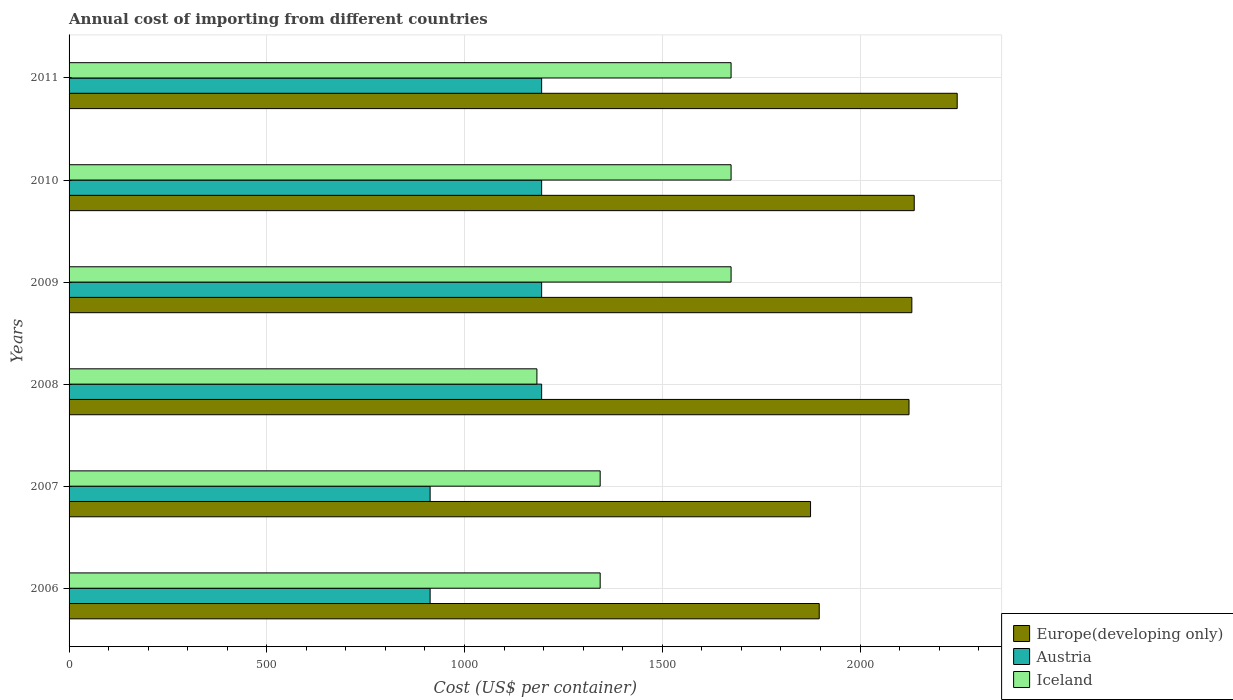How many different coloured bars are there?
Offer a terse response. 3. How many groups of bars are there?
Your answer should be very brief. 6. In how many cases, is the number of bars for a given year not equal to the number of legend labels?
Keep it short and to the point. 0. What is the total annual cost of importing in Austria in 2010?
Offer a very short reply. 1195. Across all years, what is the maximum total annual cost of importing in Iceland?
Give a very brief answer. 1674. Across all years, what is the minimum total annual cost of importing in Europe(developing only)?
Offer a very short reply. 1874.94. In which year was the total annual cost of importing in Austria maximum?
Your answer should be compact. 2008. In which year was the total annual cost of importing in Iceland minimum?
Make the answer very short. 2008. What is the total total annual cost of importing in Iceland in the graph?
Give a very brief answer. 8891. What is the difference between the total annual cost of importing in Europe(developing only) in 2006 and that in 2009?
Provide a succinct answer. -234.16. What is the difference between the total annual cost of importing in Austria in 2010 and the total annual cost of importing in Iceland in 2008?
Make the answer very short. 12. What is the average total annual cost of importing in Iceland per year?
Make the answer very short. 1481.83. In the year 2006, what is the difference between the total annual cost of importing in Europe(developing only) and total annual cost of importing in Austria?
Keep it short and to the point. 983.94. What is the ratio of the total annual cost of importing in Iceland in 2006 to that in 2010?
Provide a short and direct response. 0.8. What is the difference between the highest and the second highest total annual cost of importing in Europe(developing only)?
Keep it short and to the point. 108.63. What is the difference between the highest and the lowest total annual cost of importing in Europe(developing only)?
Provide a succinct answer. 370.85. In how many years, is the total annual cost of importing in Austria greater than the average total annual cost of importing in Austria taken over all years?
Keep it short and to the point. 4. What does the 1st bar from the top in 2011 represents?
Your answer should be compact. Iceland. How many years are there in the graph?
Offer a very short reply. 6. Does the graph contain any zero values?
Give a very brief answer. No. Does the graph contain grids?
Keep it short and to the point. Yes. What is the title of the graph?
Make the answer very short. Annual cost of importing from different countries. Does "Burundi" appear as one of the legend labels in the graph?
Provide a succinct answer. No. What is the label or title of the X-axis?
Provide a short and direct response. Cost (US$ per container). What is the label or title of the Y-axis?
Offer a very short reply. Years. What is the Cost (US$ per container) in Europe(developing only) in 2006?
Your answer should be very brief. 1896.94. What is the Cost (US$ per container) in Austria in 2006?
Give a very brief answer. 913. What is the Cost (US$ per container) in Iceland in 2006?
Keep it short and to the point. 1343. What is the Cost (US$ per container) of Europe(developing only) in 2007?
Offer a terse response. 1874.94. What is the Cost (US$ per container) in Austria in 2007?
Keep it short and to the point. 913. What is the Cost (US$ per container) in Iceland in 2007?
Your answer should be very brief. 1343. What is the Cost (US$ per container) of Europe(developing only) in 2008?
Offer a very short reply. 2123.94. What is the Cost (US$ per container) in Austria in 2008?
Offer a terse response. 1195. What is the Cost (US$ per container) in Iceland in 2008?
Your answer should be compact. 1183. What is the Cost (US$ per container) of Europe(developing only) in 2009?
Make the answer very short. 2131.11. What is the Cost (US$ per container) in Austria in 2009?
Your response must be concise. 1195. What is the Cost (US$ per container) in Iceland in 2009?
Your response must be concise. 1674. What is the Cost (US$ per container) of Europe(developing only) in 2010?
Your answer should be compact. 2137.16. What is the Cost (US$ per container) in Austria in 2010?
Your answer should be compact. 1195. What is the Cost (US$ per container) of Iceland in 2010?
Offer a very short reply. 1674. What is the Cost (US$ per container) in Europe(developing only) in 2011?
Make the answer very short. 2245.79. What is the Cost (US$ per container) in Austria in 2011?
Provide a short and direct response. 1195. What is the Cost (US$ per container) in Iceland in 2011?
Ensure brevity in your answer.  1674. Across all years, what is the maximum Cost (US$ per container) of Europe(developing only)?
Offer a terse response. 2245.79. Across all years, what is the maximum Cost (US$ per container) in Austria?
Give a very brief answer. 1195. Across all years, what is the maximum Cost (US$ per container) of Iceland?
Provide a short and direct response. 1674. Across all years, what is the minimum Cost (US$ per container) in Europe(developing only)?
Give a very brief answer. 1874.94. Across all years, what is the minimum Cost (US$ per container) in Austria?
Offer a terse response. 913. Across all years, what is the minimum Cost (US$ per container) of Iceland?
Make the answer very short. 1183. What is the total Cost (US$ per container) in Europe(developing only) in the graph?
Provide a succinct answer. 1.24e+04. What is the total Cost (US$ per container) in Austria in the graph?
Provide a succinct answer. 6606. What is the total Cost (US$ per container) in Iceland in the graph?
Give a very brief answer. 8891. What is the difference between the Cost (US$ per container) in Europe(developing only) in 2006 and that in 2007?
Provide a short and direct response. 22. What is the difference between the Cost (US$ per container) in Austria in 2006 and that in 2007?
Your answer should be very brief. 0. What is the difference between the Cost (US$ per container) of Europe(developing only) in 2006 and that in 2008?
Your answer should be very brief. -227. What is the difference between the Cost (US$ per container) of Austria in 2006 and that in 2008?
Keep it short and to the point. -282. What is the difference between the Cost (US$ per container) in Iceland in 2006 and that in 2008?
Give a very brief answer. 160. What is the difference between the Cost (US$ per container) of Europe(developing only) in 2006 and that in 2009?
Provide a succinct answer. -234.16. What is the difference between the Cost (US$ per container) of Austria in 2006 and that in 2009?
Provide a succinct answer. -282. What is the difference between the Cost (US$ per container) in Iceland in 2006 and that in 2009?
Offer a very short reply. -331. What is the difference between the Cost (US$ per container) in Europe(developing only) in 2006 and that in 2010?
Your answer should be very brief. -240.21. What is the difference between the Cost (US$ per container) in Austria in 2006 and that in 2010?
Provide a succinct answer. -282. What is the difference between the Cost (US$ per container) in Iceland in 2006 and that in 2010?
Your answer should be compact. -331. What is the difference between the Cost (US$ per container) in Europe(developing only) in 2006 and that in 2011?
Keep it short and to the point. -348.85. What is the difference between the Cost (US$ per container) in Austria in 2006 and that in 2011?
Offer a terse response. -282. What is the difference between the Cost (US$ per container) of Iceland in 2006 and that in 2011?
Make the answer very short. -331. What is the difference between the Cost (US$ per container) of Europe(developing only) in 2007 and that in 2008?
Give a very brief answer. -249. What is the difference between the Cost (US$ per container) of Austria in 2007 and that in 2008?
Offer a terse response. -282. What is the difference between the Cost (US$ per container) of Iceland in 2007 and that in 2008?
Keep it short and to the point. 160. What is the difference between the Cost (US$ per container) in Europe(developing only) in 2007 and that in 2009?
Offer a very short reply. -256.16. What is the difference between the Cost (US$ per container) in Austria in 2007 and that in 2009?
Your answer should be compact. -282. What is the difference between the Cost (US$ per container) of Iceland in 2007 and that in 2009?
Keep it short and to the point. -331. What is the difference between the Cost (US$ per container) of Europe(developing only) in 2007 and that in 2010?
Keep it short and to the point. -262.21. What is the difference between the Cost (US$ per container) of Austria in 2007 and that in 2010?
Your response must be concise. -282. What is the difference between the Cost (US$ per container) of Iceland in 2007 and that in 2010?
Give a very brief answer. -331. What is the difference between the Cost (US$ per container) of Europe(developing only) in 2007 and that in 2011?
Your answer should be compact. -370.85. What is the difference between the Cost (US$ per container) in Austria in 2007 and that in 2011?
Your response must be concise. -282. What is the difference between the Cost (US$ per container) in Iceland in 2007 and that in 2011?
Provide a short and direct response. -331. What is the difference between the Cost (US$ per container) in Europe(developing only) in 2008 and that in 2009?
Keep it short and to the point. -7.16. What is the difference between the Cost (US$ per container) of Austria in 2008 and that in 2009?
Ensure brevity in your answer.  0. What is the difference between the Cost (US$ per container) in Iceland in 2008 and that in 2009?
Provide a short and direct response. -491. What is the difference between the Cost (US$ per container) of Europe(developing only) in 2008 and that in 2010?
Your answer should be very brief. -13.21. What is the difference between the Cost (US$ per container) of Austria in 2008 and that in 2010?
Your answer should be very brief. 0. What is the difference between the Cost (US$ per container) of Iceland in 2008 and that in 2010?
Make the answer very short. -491. What is the difference between the Cost (US$ per container) of Europe(developing only) in 2008 and that in 2011?
Your answer should be very brief. -121.84. What is the difference between the Cost (US$ per container) in Iceland in 2008 and that in 2011?
Your answer should be very brief. -491. What is the difference between the Cost (US$ per container) in Europe(developing only) in 2009 and that in 2010?
Offer a very short reply. -6.05. What is the difference between the Cost (US$ per container) in Iceland in 2009 and that in 2010?
Offer a very short reply. 0. What is the difference between the Cost (US$ per container) of Europe(developing only) in 2009 and that in 2011?
Provide a succinct answer. -114.68. What is the difference between the Cost (US$ per container) of Austria in 2009 and that in 2011?
Keep it short and to the point. 0. What is the difference between the Cost (US$ per container) in Iceland in 2009 and that in 2011?
Make the answer very short. 0. What is the difference between the Cost (US$ per container) of Europe(developing only) in 2010 and that in 2011?
Keep it short and to the point. -108.63. What is the difference between the Cost (US$ per container) in Europe(developing only) in 2006 and the Cost (US$ per container) in Austria in 2007?
Keep it short and to the point. 983.94. What is the difference between the Cost (US$ per container) of Europe(developing only) in 2006 and the Cost (US$ per container) of Iceland in 2007?
Ensure brevity in your answer.  553.94. What is the difference between the Cost (US$ per container) of Austria in 2006 and the Cost (US$ per container) of Iceland in 2007?
Your response must be concise. -430. What is the difference between the Cost (US$ per container) of Europe(developing only) in 2006 and the Cost (US$ per container) of Austria in 2008?
Your answer should be very brief. 701.94. What is the difference between the Cost (US$ per container) of Europe(developing only) in 2006 and the Cost (US$ per container) of Iceland in 2008?
Your response must be concise. 713.94. What is the difference between the Cost (US$ per container) of Austria in 2006 and the Cost (US$ per container) of Iceland in 2008?
Your answer should be compact. -270. What is the difference between the Cost (US$ per container) in Europe(developing only) in 2006 and the Cost (US$ per container) in Austria in 2009?
Offer a very short reply. 701.94. What is the difference between the Cost (US$ per container) of Europe(developing only) in 2006 and the Cost (US$ per container) of Iceland in 2009?
Your response must be concise. 222.94. What is the difference between the Cost (US$ per container) of Austria in 2006 and the Cost (US$ per container) of Iceland in 2009?
Offer a very short reply. -761. What is the difference between the Cost (US$ per container) of Europe(developing only) in 2006 and the Cost (US$ per container) of Austria in 2010?
Your answer should be compact. 701.94. What is the difference between the Cost (US$ per container) of Europe(developing only) in 2006 and the Cost (US$ per container) of Iceland in 2010?
Your response must be concise. 222.94. What is the difference between the Cost (US$ per container) of Austria in 2006 and the Cost (US$ per container) of Iceland in 2010?
Ensure brevity in your answer.  -761. What is the difference between the Cost (US$ per container) of Europe(developing only) in 2006 and the Cost (US$ per container) of Austria in 2011?
Keep it short and to the point. 701.94. What is the difference between the Cost (US$ per container) of Europe(developing only) in 2006 and the Cost (US$ per container) of Iceland in 2011?
Ensure brevity in your answer.  222.94. What is the difference between the Cost (US$ per container) in Austria in 2006 and the Cost (US$ per container) in Iceland in 2011?
Provide a short and direct response. -761. What is the difference between the Cost (US$ per container) of Europe(developing only) in 2007 and the Cost (US$ per container) of Austria in 2008?
Provide a short and direct response. 679.94. What is the difference between the Cost (US$ per container) in Europe(developing only) in 2007 and the Cost (US$ per container) in Iceland in 2008?
Ensure brevity in your answer.  691.94. What is the difference between the Cost (US$ per container) of Austria in 2007 and the Cost (US$ per container) of Iceland in 2008?
Offer a very short reply. -270. What is the difference between the Cost (US$ per container) in Europe(developing only) in 2007 and the Cost (US$ per container) in Austria in 2009?
Give a very brief answer. 679.94. What is the difference between the Cost (US$ per container) of Europe(developing only) in 2007 and the Cost (US$ per container) of Iceland in 2009?
Offer a terse response. 200.94. What is the difference between the Cost (US$ per container) of Austria in 2007 and the Cost (US$ per container) of Iceland in 2009?
Ensure brevity in your answer.  -761. What is the difference between the Cost (US$ per container) in Europe(developing only) in 2007 and the Cost (US$ per container) in Austria in 2010?
Ensure brevity in your answer.  679.94. What is the difference between the Cost (US$ per container) of Europe(developing only) in 2007 and the Cost (US$ per container) of Iceland in 2010?
Your response must be concise. 200.94. What is the difference between the Cost (US$ per container) of Austria in 2007 and the Cost (US$ per container) of Iceland in 2010?
Ensure brevity in your answer.  -761. What is the difference between the Cost (US$ per container) of Europe(developing only) in 2007 and the Cost (US$ per container) of Austria in 2011?
Make the answer very short. 679.94. What is the difference between the Cost (US$ per container) of Europe(developing only) in 2007 and the Cost (US$ per container) of Iceland in 2011?
Keep it short and to the point. 200.94. What is the difference between the Cost (US$ per container) of Austria in 2007 and the Cost (US$ per container) of Iceland in 2011?
Offer a terse response. -761. What is the difference between the Cost (US$ per container) of Europe(developing only) in 2008 and the Cost (US$ per container) of Austria in 2009?
Your response must be concise. 928.94. What is the difference between the Cost (US$ per container) of Europe(developing only) in 2008 and the Cost (US$ per container) of Iceland in 2009?
Ensure brevity in your answer.  449.94. What is the difference between the Cost (US$ per container) in Austria in 2008 and the Cost (US$ per container) in Iceland in 2009?
Make the answer very short. -479. What is the difference between the Cost (US$ per container) of Europe(developing only) in 2008 and the Cost (US$ per container) of Austria in 2010?
Provide a short and direct response. 928.94. What is the difference between the Cost (US$ per container) in Europe(developing only) in 2008 and the Cost (US$ per container) in Iceland in 2010?
Make the answer very short. 449.94. What is the difference between the Cost (US$ per container) of Austria in 2008 and the Cost (US$ per container) of Iceland in 2010?
Provide a short and direct response. -479. What is the difference between the Cost (US$ per container) of Europe(developing only) in 2008 and the Cost (US$ per container) of Austria in 2011?
Make the answer very short. 928.94. What is the difference between the Cost (US$ per container) of Europe(developing only) in 2008 and the Cost (US$ per container) of Iceland in 2011?
Your answer should be compact. 449.94. What is the difference between the Cost (US$ per container) in Austria in 2008 and the Cost (US$ per container) in Iceland in 2011?
Your response must be concise. -479. What is the difference between the Cost (US$ per container) of Europe(developing only) in 2009 and the Cost (US$ per container) of Austria in 2010?
Keep it short and to the point. 936.11. What is the difference between the Cost (US$ per container) of Europe(developing only) in 2009 and the Cost (US$ per container) of Iceland in 2010?
Your response must be concise. 457.11. What is the difference between the Cost (US$ per container) of Austria in 2009 and the Cost (US$ per container) of Iceland in 2010?
Offer a terse response. -479. What is the difference between the Cost (US$ per container) in Europe(developing only) in 2009 and the Cost (US$ per container) in Austria in 2011?
Your answer should be very brief. 936.11. What is the difference between the Cost (US$ per container) in Europe(developing only) in 2009 and the Cost (US$ per container) in Iceland in 2011?
Provide a short and direct response. 457.11. What is the difference between the Cost (US$ per container) of Austria in 2009 and the Cost (US$ per container) of Iceland in 2011?
Offer a terse response. -479. What is the difference between the Cost (US$ per container) in Europe(developing only) in 2010 and the Cost (US$ per container) in Austria in 2011?
Make the answer very short. 942.16. What is the difference between the Cost (US$ per container) in Europe(developing only) in 2010 and the Cost (US$ per container) in Iceland in 2011?
Give a very brief answer. 463.16. What is the difference between the Cost (US$ per container) in Austria in 2010 and the Cost (US$ per container) in Iceland in 2011?
Your answer should be very brief. -479. What is the average Cost (US$ per container) of Europe(developing only) per year?
Your answer should be very brief. 2068.31. What is the average Cost (US$ per container) of Austria per year?
Offer a very short reply. 1101. What is the average Cost (US$ per container) of Iceland per year?
Make the answer very short. 1481.83. In the year 2006, what is the difference between the Cost (US$ per container) in Europe(developing only) and Cost (US$ per container) in Austria?
Your response must be concise. 983.94. In the year 2006, what is the difference between the Cost (US$ per container) of Europe(developing only) and Cost (US$ per container) of Iceland?
Your answer should be very brief. 553.94. In the year 2006, what is the difference between the Cost (US$ per container) in Austria and Cost (US$ per container) in Iceland?
Provide a short and direct response. -430. In the year 2007, what is the difference between the Cost (US$ per container) of Europe(developing only) and Cost (US$ per container) of Austria?
Provide a succinct answer. 961.94. In the year 2007, what is the difference between the Cost (US$ per container) in Europe(developing only) and Cost (US$ per container) in Iceland?
Your answer should be compact. 531.94. In the year 2007, what is the difference between the Cost (US$ per container) of Austria and Cost (US$ per container) of Iceland?
Keep it short and to the point. -430. In the year 2008, what is the difference between the Cost (US$ per container) in Europe(developing only) and Cost (US$ per container) in Austria?
Your answer should be very brief. 928.94. In the year 2008, what is the difference between the Cost (US$ per container) in Europe(developing only) and Cost (US$ per container) in Iceland?
Your answer should be compact. 940.94. In the year 2009, what is the difference between the Cost (US$ per container) of Europe(developing only) and Cost (US$ per container) of Austria?
Provide a short and direct response. 936.11. In the year 2009, what is the difference between the Cost (US$ per container) of Europe(developing only) and Cost (US$ per container) of Iceland?
Offer a terse response. 457.11. In the year 2009, what is the difference between the Cost (US$ per container) in Austria and Cost (US$ per container) in Iceland?
Your answer should be compact. -479. In the year 2010, what is the difference between the Cost (US$ per container) in Europe(developing only) and Cost (US$ per container) in Austria?
Your response must be concise. 942.16. In the year 2010, what is the difference between the Cost (US$ per container) in Europe(developing only) and Cost (US$ per container) in Iceland?
Make the answer very short. 463.16. In the year 2010, what is the difference between the Cost (US$ per container) in Austria and Cost (US$ per container) in Iceland?
Offer a terse response. -479. In the year 2011, what is the difference between the Cost (US$ per container) in Europe(developing only) and Cost (US$ per container) in Austria?
Your response must be concise. 1050.79. In the year 2011, what is the difference between the Cost (US$ per container) in Europe(developing only) and Cost (US$ per container) in Iceland?
Your response must be concise. 571.79. In the year 2011, what is the difference between the Cost (US$ per container) in Austria and Cost (US$ per container) in Iceland?
Make the answer very short. -479. What is the ratio of the Cost (US$ per container) in Europe(developing only) in 2006 to that in 2007?
Keep it short and to the point. 1.01. What is the ratio of the Cost (US$ per container) of Iceland in 2006 to that in 2007?
Your answer should be compact. 1. What is the ratio of the Cost (US$ per container) of Europe(developing only) in 2006 to that in 2008?
Provide a succinct answer. 0.89. What is the ratio of the Cost (US$ per container) of Austria in 2006 to that in 2008?
Ensure brevity in your answer.  0.76. What is the ratio of the Cost (US$ per container) of Iceland in 2006 to that in 2008?
Provide a succinct answer. 1.14. What is the ratio of the Cost (US$ per container) in Europe(developing only) in 2006 to that in 2009?
Provide a short and direct response. 0.89. What is the ratio of the Cost (US$ per container) of Austria in 2006 to that in 2009?
Provide a succinct answer. 0.76. What is the ratio of the Cost (US$ per container) of Iceland in 2006 to that in 2009?
Your response must be concise. 0.8. What is the ratio of the Cost (US$ per container) in Europe(developing only) in 2006 to that in 2010?
Give a very brief answer. 0.89. What is the ratio of the Cost (US$ per container) in Austria in 2006 to that in 2010?
Ensure brevity in your answer.  0.76. What is the ratio of the Cost (US$ per container) in Iceland in 2006 to that in 2010?
Provide a short and direct response. 0.8. What is the ratio of the Cost (US$ per container) in Europe(developing only) in 2006 to that in 2011?
Keep it short and to the point. 0.84. What is the ratio of the Cost (US$ per container) of Austria in 2006 to that in 2011?
Give a very brief answer. 0.76. What is the ratio of the Cost (US$ per container) in Iceland in 2006 to that in 2011?
Keep it short and to the point. 0.8. What is the ratio of the Cost (US$ per container) in Europe(developing only) in 2007 to that in 2008?
Make the answer very short. 0.88. What is the ratio of the Cost (US$ per container) of Austria in 2007 to that in 2008?
Your answer should be very brief. 0.76. What is the ratio of the Cost (US$ per container) in Iceland in 2007 to that in 2008?
Offer a very short reply. 1.14. What is the ratio of the Cost (US$ per container) of Europe(developing only) in 2007 to that in 2009?
Give a very brief answer. 0.88. What is the ratio of the Cost (US$ per container) of Austria in 2007 to that in 2009?
Provide a succinct answer. 0.76. What is the ratio of the Cost (US$ per container) of Iceland in 2007 to that in 2009?
Provide a short and direct response. 0.8. What is the ratio of the Cost (US$ per container) of Europe(developing only) in 2007 to that in 2010?
Ensure brevity in your answer.  0.88. What is the ratio of the Cost (US$ per container) of Austria in 2007 to that in 2010?
Keep it short and to the point. 0.76. What is the ratio of the Cost (US$ per container) in Iceland in 2007 to that in 2010?
Your response must be concise. 0.8. What is the ratio of the Cost (US$ per container) of Europe(developing only) in 2007 to that in 2011?
Your answer should be compact. 0.83. What is the ratio of the Cost (US$ per container) in Austria in 2007 to that in 2011?
Your answer should be compact. 0.76. What is the ratio of the Cost (US$ per container) in Iceland in 2007 to that in 2011?
Offer a very short reply. 0.8. What is the ratio of the Cost (US$ per container) of Iceland in 2008 to that in 2009?
Your answer should be compact. 0.71. What is the ratio of the Cost (US$ per container) of Europe(developing only) in 2008 to that in 2010?
Offer a terse response. 0.99. What is the ratio of the Cost (US$ per container) of Iceland in 2008 to that in 2010?
Your answer should be compact. 0.71. What is the ratio of the Cost (US$ per container) of Europe(developing only) in 2008 to that in 2011?
Your answer should be very brief. 0.95. What is the ratio of the Cost (US$ per container) in Iceland in 2008 to that in 2011?
Make the answer very short. 0.71. What is the ratio of the Cost (US$ per container) of Europe(developing only) in 2009 to that in 2010?
Offer a terse response. 1. What is the ratio of the Cost (US$ per container) in Iceland in 2009 to that in 2010?
Keep it short and to the point. 1. What is the ratio of the Cost (US$ per container) in Europe(developing only) in 2009 to that in 2011?
Your answer should be compact. 0.95. What is the ratio of the Cost (US$ per container) of Austria in 2009 to that in 2011?
Provide a succinct answer. 1. What is the ratio of the Cost (US$ per container) in Europe(developing only) in 2010 to that in 2011?
Your answer should be very brief. 0.95. What is the ratio of the Cost (US$ per container) of Iceland in 2010 to that in 2011?
Your response must be concise. 1. What is the difference between the highest and the second highest Cost (US$ per container) in Europe(developing only)?
Provide a succinct answer. 108.63. What is the difference between the highest and the lowest Cost (US$ per container) in Europe(developing only)?
Provide a succinct answer. 370.85. What is the difference between the highest and the lowest Cost (US$ per container) of Austria?
Your answer should be very brief. 282. What is the difference between the highest and the lowest Cost (US$ per container) in Iceland?
Provide a succinct answer. 491. 